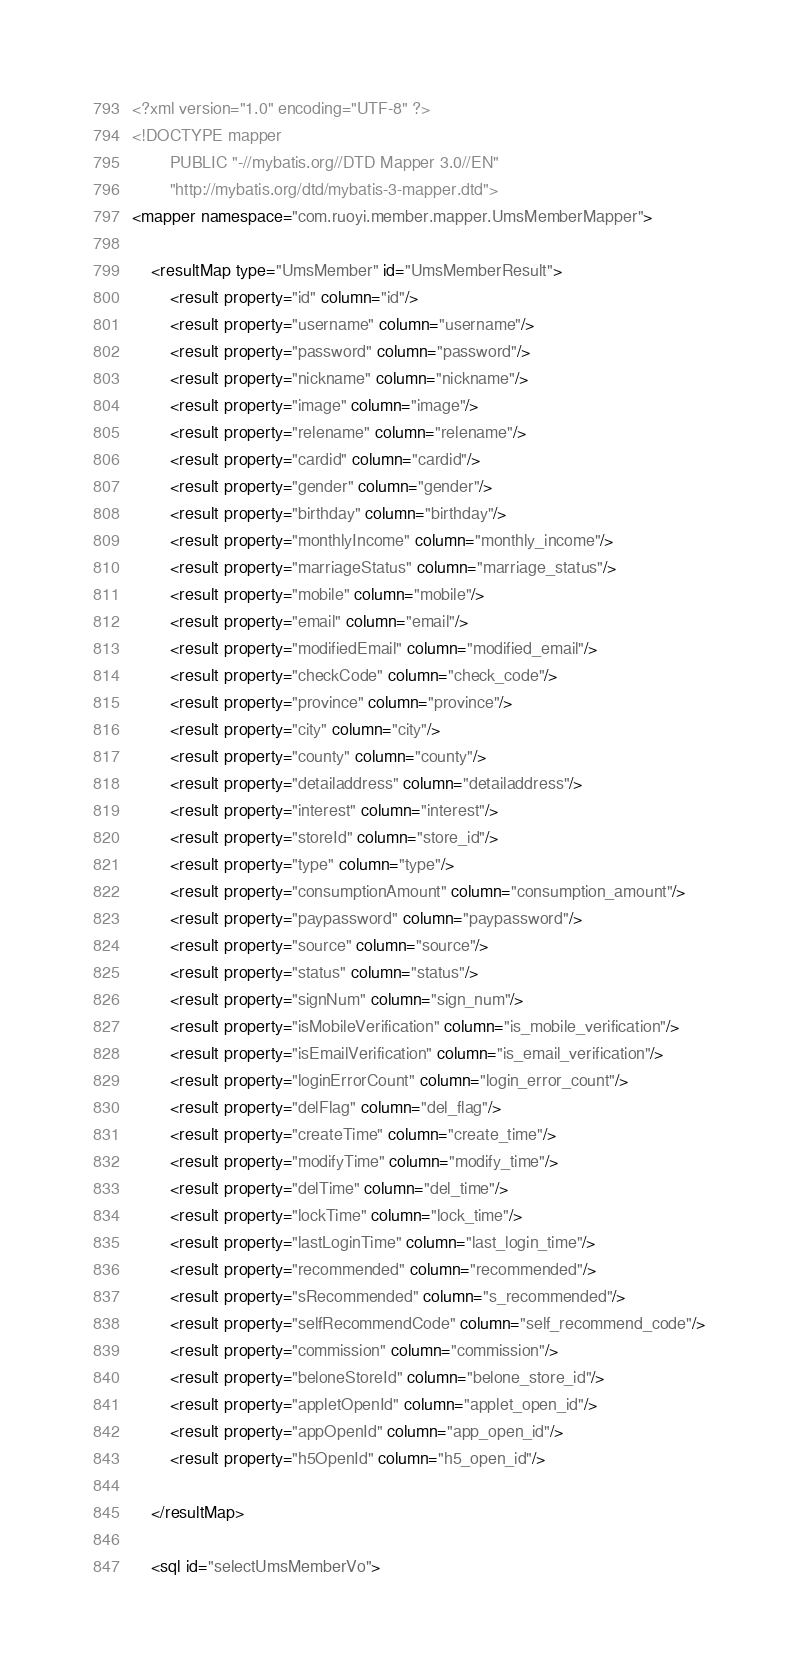<code> <loc_0><loc_0><loc_500><loc_500><_XML_><?xml version="1.0" encoding="UTF-8" ?>
<!DOCTYPE mapper
        PUBLIC "-//mybatis.org//DTD Mapper 3.0//EN"
        "http://mybatis.org/dtd/mybatis-3-mapper.dtd">
<mapper namespace="com.ruoyi.member.mapper.UmsMemberMapper">

    <resultMap type="UmsMember" id="UmsMemberResult">
        <result property="id" column="id"/>
        <result property="username" column="username"/>
        <result property="password" column="password"/>
        <result property="nickname" column="nickname"/>
        <result property="image" column="image"/>
        <result property="relename" column="relename"/>
        <result property="cardid" column="cardid"/>
        <result property="gender" column="gender"/>
        <result property="birthday" column="birthday"/>
        <result property="monthlyIncome" column="monthly_income"/>
        <result property="marriageStatus" column="marriage_status"/>
        <result property="mobile" column="mobile"/>
        <result property="email" column="email"/>
        <result property="modifiedEmail" column="modified_email"/>
        <result property="checkCode" column="check_code"/>
        <result property="province" column="province"/>
        <result property="city" column="city"/>
        <result property="county" column="county"/>
        <result property="detailaddress" column="detailaddress"/>
        <result property="interest" column="interest"/>
        <result property="storeId" column="store_id"/>
        <result property="type" column="type"/>
        <result property="consumptionAmount" column="consumption_amount"/>
        <result property="paypassword" column="paypassword"/>
        <result property="source" column="source"/>
        <result property="status" column="status"/>
        <result property="signNum" column="sign_num"/>
        <result property="isMobileVerification" column="is_mobile_verification"/>
        <result property="isEmailVerification" column="is_email_verification"/>
        <result property="loginErrorCount" column="login_error_count"/>
        <result property="delFlag" column="del_flag"/>
        <result property="createTime" column="create_time"/>
        <result property="modifyTime" column="modify_time"/>
        <result property="delTime" column="del_time"/>
        <result property="lockTime" column="lock_time"/>
        <result property="lastLoginTime" column="last_login_time"/>
        <result property="recommended" column="recommended"/>
        <result property="sRecommended" column="s_recommended"/>
        <result property="selfRecommendCode" column="self_recommend_code"/>
        <result property="commission" column="commission"/>
        <result property="beloneStoreId" column="belone_store_id"/>
        <result property="appletOpenId" column="applet_open_id"/>
        <result property="appOpenId" column="app_open_id"/>
        <result property="h5OpenId" column="h5_open_id"/>

    </resultMap>

    <sql id="selectUmsMemberVo"></code> 